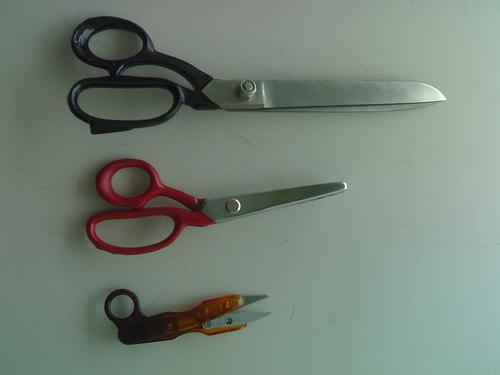Question: what color is the middle pair of scissors?
Choices:
A. Red.
B. Blue.
C. Yellow.
D. Black.
Answer with the letter. Answer: A Question: what color is the bottom pair of scissors?
Choices:
A. Purple.
B. Yellow.
C. Green.
D. Orange.
Answer with the letter. Answer: D Question: when would these scissors be used?
Choices:
A. Cut food.
B. Cut paper.
C. Cut magazine.
D. To cut things.
Answer with the letter. Answer: D 